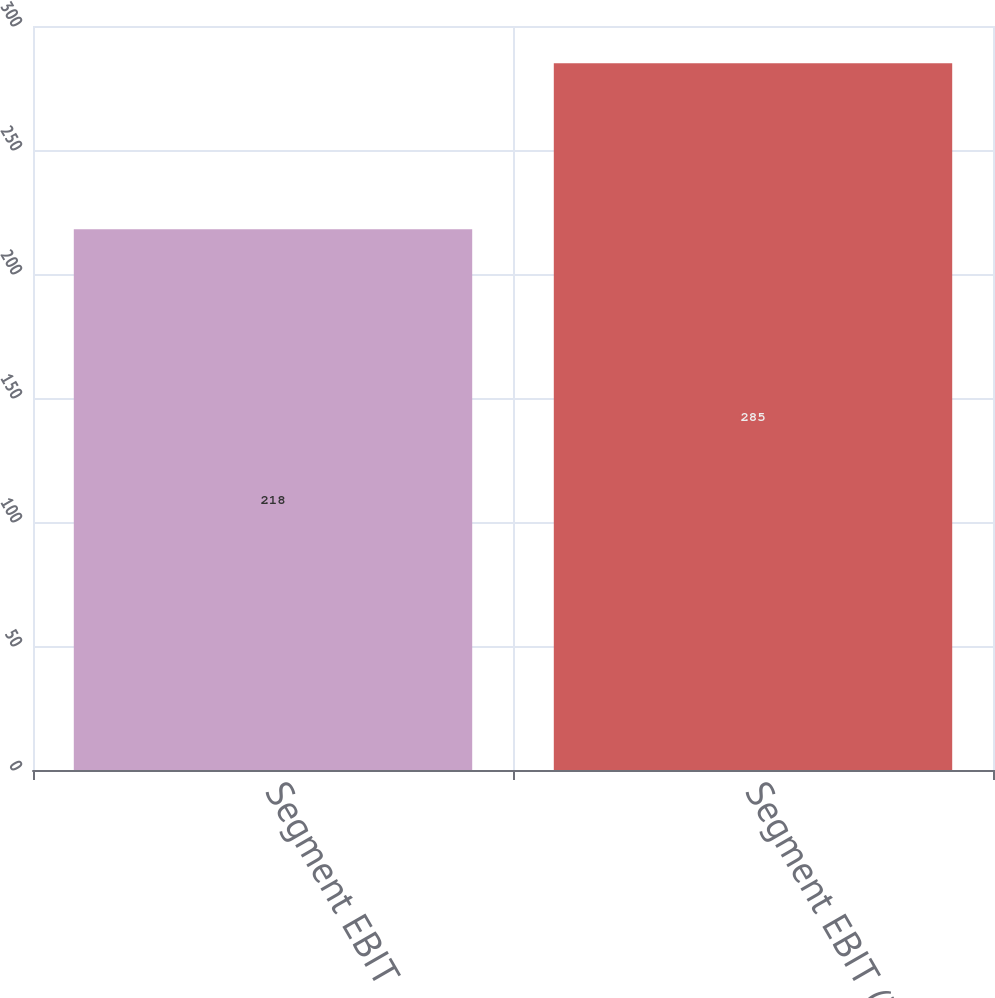Convert chart. <chart><loc_0><loc_0><loc_500><loc_500><bar_chart><fcel>Segment EBIT<fcel>Segment EBIT (3)<nl><fcel>218<fcel>285<nl></chart> 